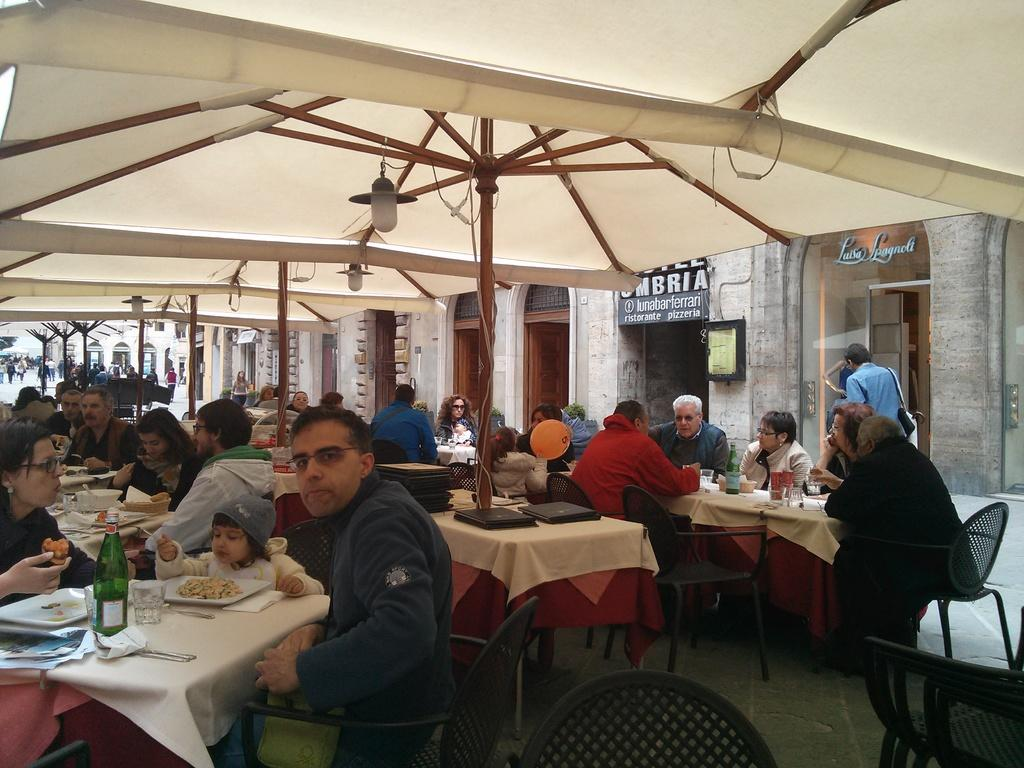What type of setting is shown in the image? The image depicts a restaurant setting. Can you describe the people in the image? There is a group of people seated in the image. What are the people doing in the image? The people are having food in the image. What objects can be seen on the table in the image? There are plates, glasses, and water bottles on the table. What type of destruction can be seen happening to the restaurant in the image? There is no destruction present in the image; it depicts a normal restaurant setting with people having food. 